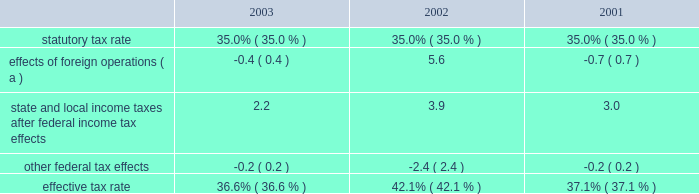Expenditures and acquisitions of leased properties are funded by the original contributor of the assets , but no change in ownership interest may result from these contributions .
An excess of ashland funded improvements over marathon funded improvements results in a net gain and an excess of marathon funded improvements over ashland funded improvements results in a net loss .
Cost of revenues increased by $ 8.718 billion in 2003 from 2002 and $ 367 million in 2002 from 2001 .
The increases in the oerb segment were primarily a result of higher natural gas and liquid hydrocarbon costs .
The increases in the rm&t segment primarily reflected higher acquisition costs for crude oil , refined products , refinery charge and blend feedstocks and increased manufacturing expenses .
Selling , general and administrative expenses increased by $ 107 million in 2003 from 2002 and $ 125 million in 2002 from 2001 .
The increase in 2003 was primarily a result of increased employee benefits ( caused by increased pension expense resulting from changes in actuarial assumptions and a decrease in realized returns on plan assets ) and other employee related costs .
Also , marathon changed assumptions in the health care cost trend rate from 7.5% ( 7.5 % ) to 10% ( 10 % ) , resulting in higher retiree health care costs .
Additionally , during 2003 , marathon recorded a charge of $ 24 million related to organizational and business process changes .
The increase in 2002 primarily reflected increased employee related costs .
Inventory market valuation reserve is established to reduce the cost basis of inventories to current market value .
The 2002 results of operations include credits to income from operations of $ 71 million , reversing the imv reserve at december 31 , 2001 .
For additional information on this adjustment , see 201cmanagement 2019s discussion and analysis of critical accounting estimates 2013 net realizable value of inventories 201d on page 31 .
Net interest and other financial costs decreased by $ 82 million in 2003 from 2002 , following an increase of $ 96 million in 2002 from 2001 .
The decrease in 2003 is primarily due to an increase in capitalized interest related to increased long-term construction projects , the favorable effect of interest rate swaps , the favorable effect of interest on tax deficiencies and increased interest income on investments .
The increase in 2002 was primarily due to higher average debt levels resulting from acquisitions and the separation .
Additionally , included in net interest and other financing costs are foreign currency gains of $ 13 million and $ 8 million for 2003 and 2002 and losses of $ 5 million for 2001 .
Loss from early extinguishment of debt in 2002 was attributable to the retirement of $ 337 million aggregate principal amount of debt , resulting in a loss of $ 53 million .
As a result of the adoption of statement of financial accounting standards no .
145 201crescission of fasb statements no .
4 , 44 , and 64 , amendment of fasb statement no .
13 , and technical corrections 201d ( 201csfas no .
145 201d ) , the loss from early extinguishment of debt that was previously reported as an extraordinary item ( net of taxes of $ 20 million ) has been reclassified into income before income taxes .
The adoption of sfas no .
145 had no impact on net income for 2002 .
Minority interest in income of map , which represents ashland 2019s 38 percent ownership interest , increased by $ 129 million in 2003 from 2002 , following a decrease of $ 531 million in 2002 from 2001 .
Map income was higher in 2003 compared to 2002 as discussed below in the rm&t segment .
Map income was significantly lower in 2002 compared to 2001 as discussed below in the rm&t segment .
Provision for income taxes increased by $ 215 million in 2003 from 2002 , following a decrease of $ 458 million in 2002 from 2001 , primarily due to $ 720 million increase and $ 1.356 billion decrease in income before income taxes .
The effective tax rate for 2003 was 36.6% ( 36.6 % ) compared to 42.1% ( 42.1 % ) and 37.1% ( 37.1 % ) for 2002 and 2001 .
The higher rate in 2002 was due to the united kingdom enactment of a supplementary 10 percent tax on profits from the north sea oil and gas production , retroactively effective to april 17 , 2002 .
In 2002 , marathon recognized a one-time noncash deferred tax adjustment of $ 61 million as a result of the rate increase .
The following is an analysis of the effective tax rate for the periods presented: .
( a ) the deferred tax effect related to the enactment of a supplemental tax in the u.k .
Increased the effective tax rate 7.0 percent in 2002. .
What was the percentage decrease of state and local income taxes after federal income tax effects from 2002 to 2003? 
Computations: ((2.2 - 3.9) / 3.9)
Answer: -0.4359. 